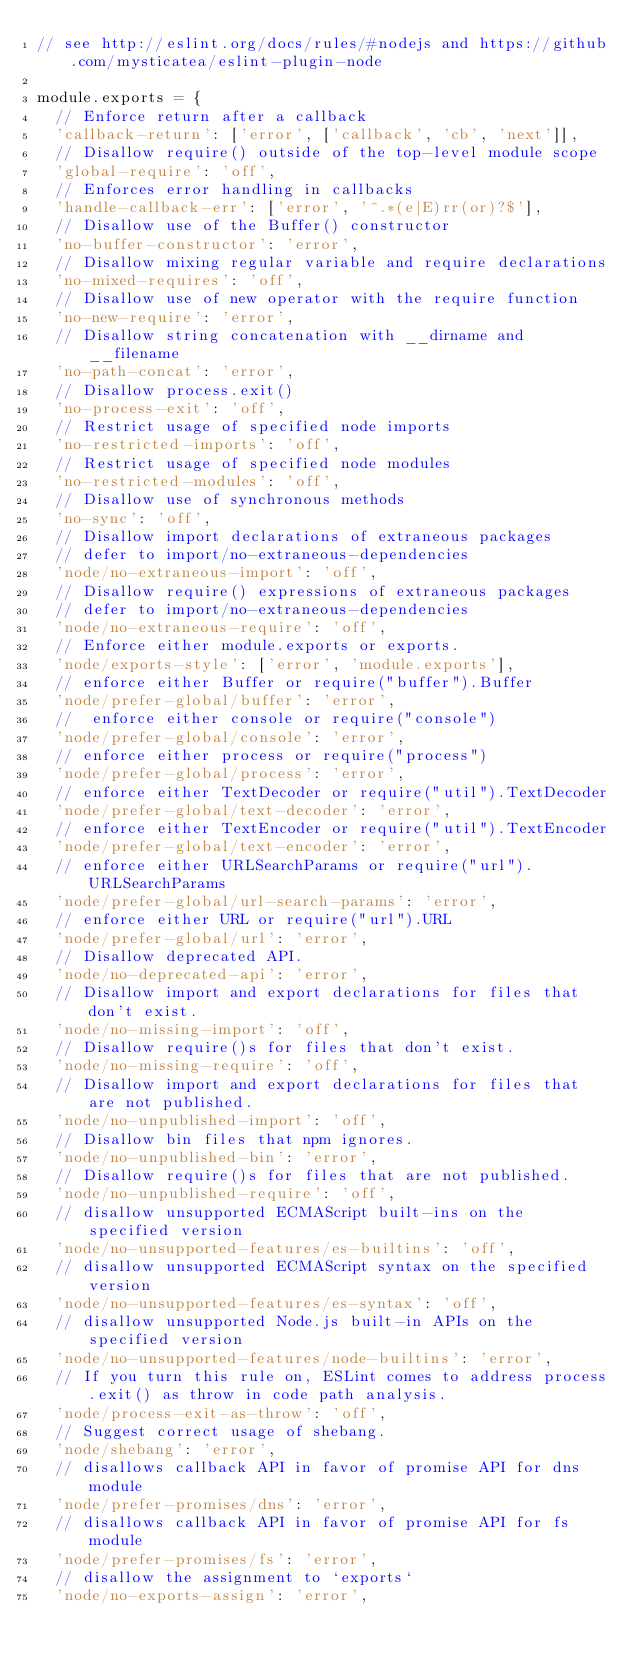Convert code to text. <code><loc_0><loc_0><loc_500><loc_500><_JavaScript_>// see http://eslint.org/docs/rules/#nodejs and https://github.com/mysticatea/eslint-plugin-node

module.exports = {
  // Enforce return after a callback
  'callback-return': ['error', ['callback', 'cb', 'next']],
  // Disallow require() outside of the top-level module scope
  'global-require': 'off',
  // Enforces error handling in callbacks
  'handle-callback-err': ['error', '^.*(e|E)rr(or)?$'],
  // Disallow use of the Buffer() constructor
  'no-buffer-constructor': 'error',
  // Disallow mixing regular variable and require declarations
  'no-mixed-requires': 'off',
  // Disallow use of new operator with the require function
  'no-new-require': 'error',
  // Disallow string concatenation with __dirname and __filename
  'no-path-concat': 'error',
  // Disallow process.exit()
  'no-process-exit': 'off',
  // Restrict usage of specified node imports
  'no-restricted-imports': 'off',
  // Restrict usage of specified node modules
  'no-restricted-modules': 'off',
  // Disallow use of synchronous methods
  'no-sync': 'off',
  // Disallow import declarations of extraneous packages
  // defer to import/no-extraneous-dependencies
  'node/no-extraneous-import': 'off',
  // Disallow require() expressions of extraneous packages
  // defer to import/no-extraneous-dependencies
  'node/no-extraneous-require': 'off',
  // Enforce either module.exports or exports.
  'node/exports-style': ['error', 'module.exports'],
  // enforce either Buffer or require("buffer").Buffer
  'node/prefer-global/buffer': 'error',
  //	enforce either console or require("console")
  'node/prefer-global/console': 'error',
  // enforce either process or require("process")
  'node/prefer-global/process': 'error',
  // enforce either TextDecoder or require("util").TextDecoder
  'node/prefer-global/text-decoder': 'error',
  // enforce either TextEncoder or require("util").TextEncoder
  'node/prefer-global/text-encoder': 'error',
  // enforce either URLSearchParams or require("url").URLSearchParams
  'node/prefer-global/url-search-params': 'error',
  // enforce either URL or require("url").URL
  'node/prefer-global/url': 'error',
  // Disallow deprecated API.
  'node/no-deprecated-api': 'error',
  // Disallow import and export declarations for files that don't exist.
  'node/no-missing-import': 'off',
  // Disallow require()s for files that don't exist.
  'node/no-missing-require': 'off',
  // Disallow import and export declarations for files that are not published.
  'node/no-unpublished-import': 'off',
  // Disallow bin files that npm ignores.
  'node/no-unpublished-bin': 'error',
  // Disallow require()s for files that are not published.
  'node/no-unpublished-require': 'off',
  // disallow unsupported ECMAScript built-ins on the specified version
  'node/no-unsupported-features/es-builtins': 'off',
  // disallow unsupported ECMAScript syntax on the specified version
  'node/no-unsupported-features/es-syntax': 'off',
  // disallow unsupported Node.js built-in APIs on the specified version
  'node/no-unsupported-features/node-builtins': 'error',
  // If you turn this rule on, ESLint comes to address process.exit() as throw in code path analysis.
  'node/process-exit-as-throw': 'off',
  // Suggest correct usage of shebang.
  'node/shebang': 'error',
  // disallows callback API in favor of promise API for dns module
  'node/prefer-promises/dns': 'error',
  // disallows callback API in favor of promise API for fs module
  'node/prefer-promises/fs': 'error',
  // disallow the assignment to `exports`
  'node/no-exports-assign': 'error',</code> 